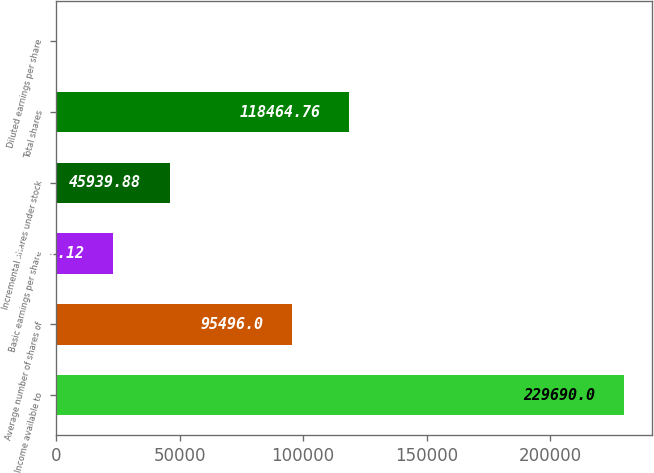<chart> <loc_0><loc_0><loc_500><loc_500><bar_chart><fcel>Income available to<fcel>Average number of shares of<fcel>Basic earnings per share<fcel>Incremental shares under stock<fcel>Total shares<fcel>Diluted earnings per share<nl><fcel>229690<fcel>95496<fcel>22971.1<fcel>45939.9<fcel>118465<fcel>2.36<nl></chart> 